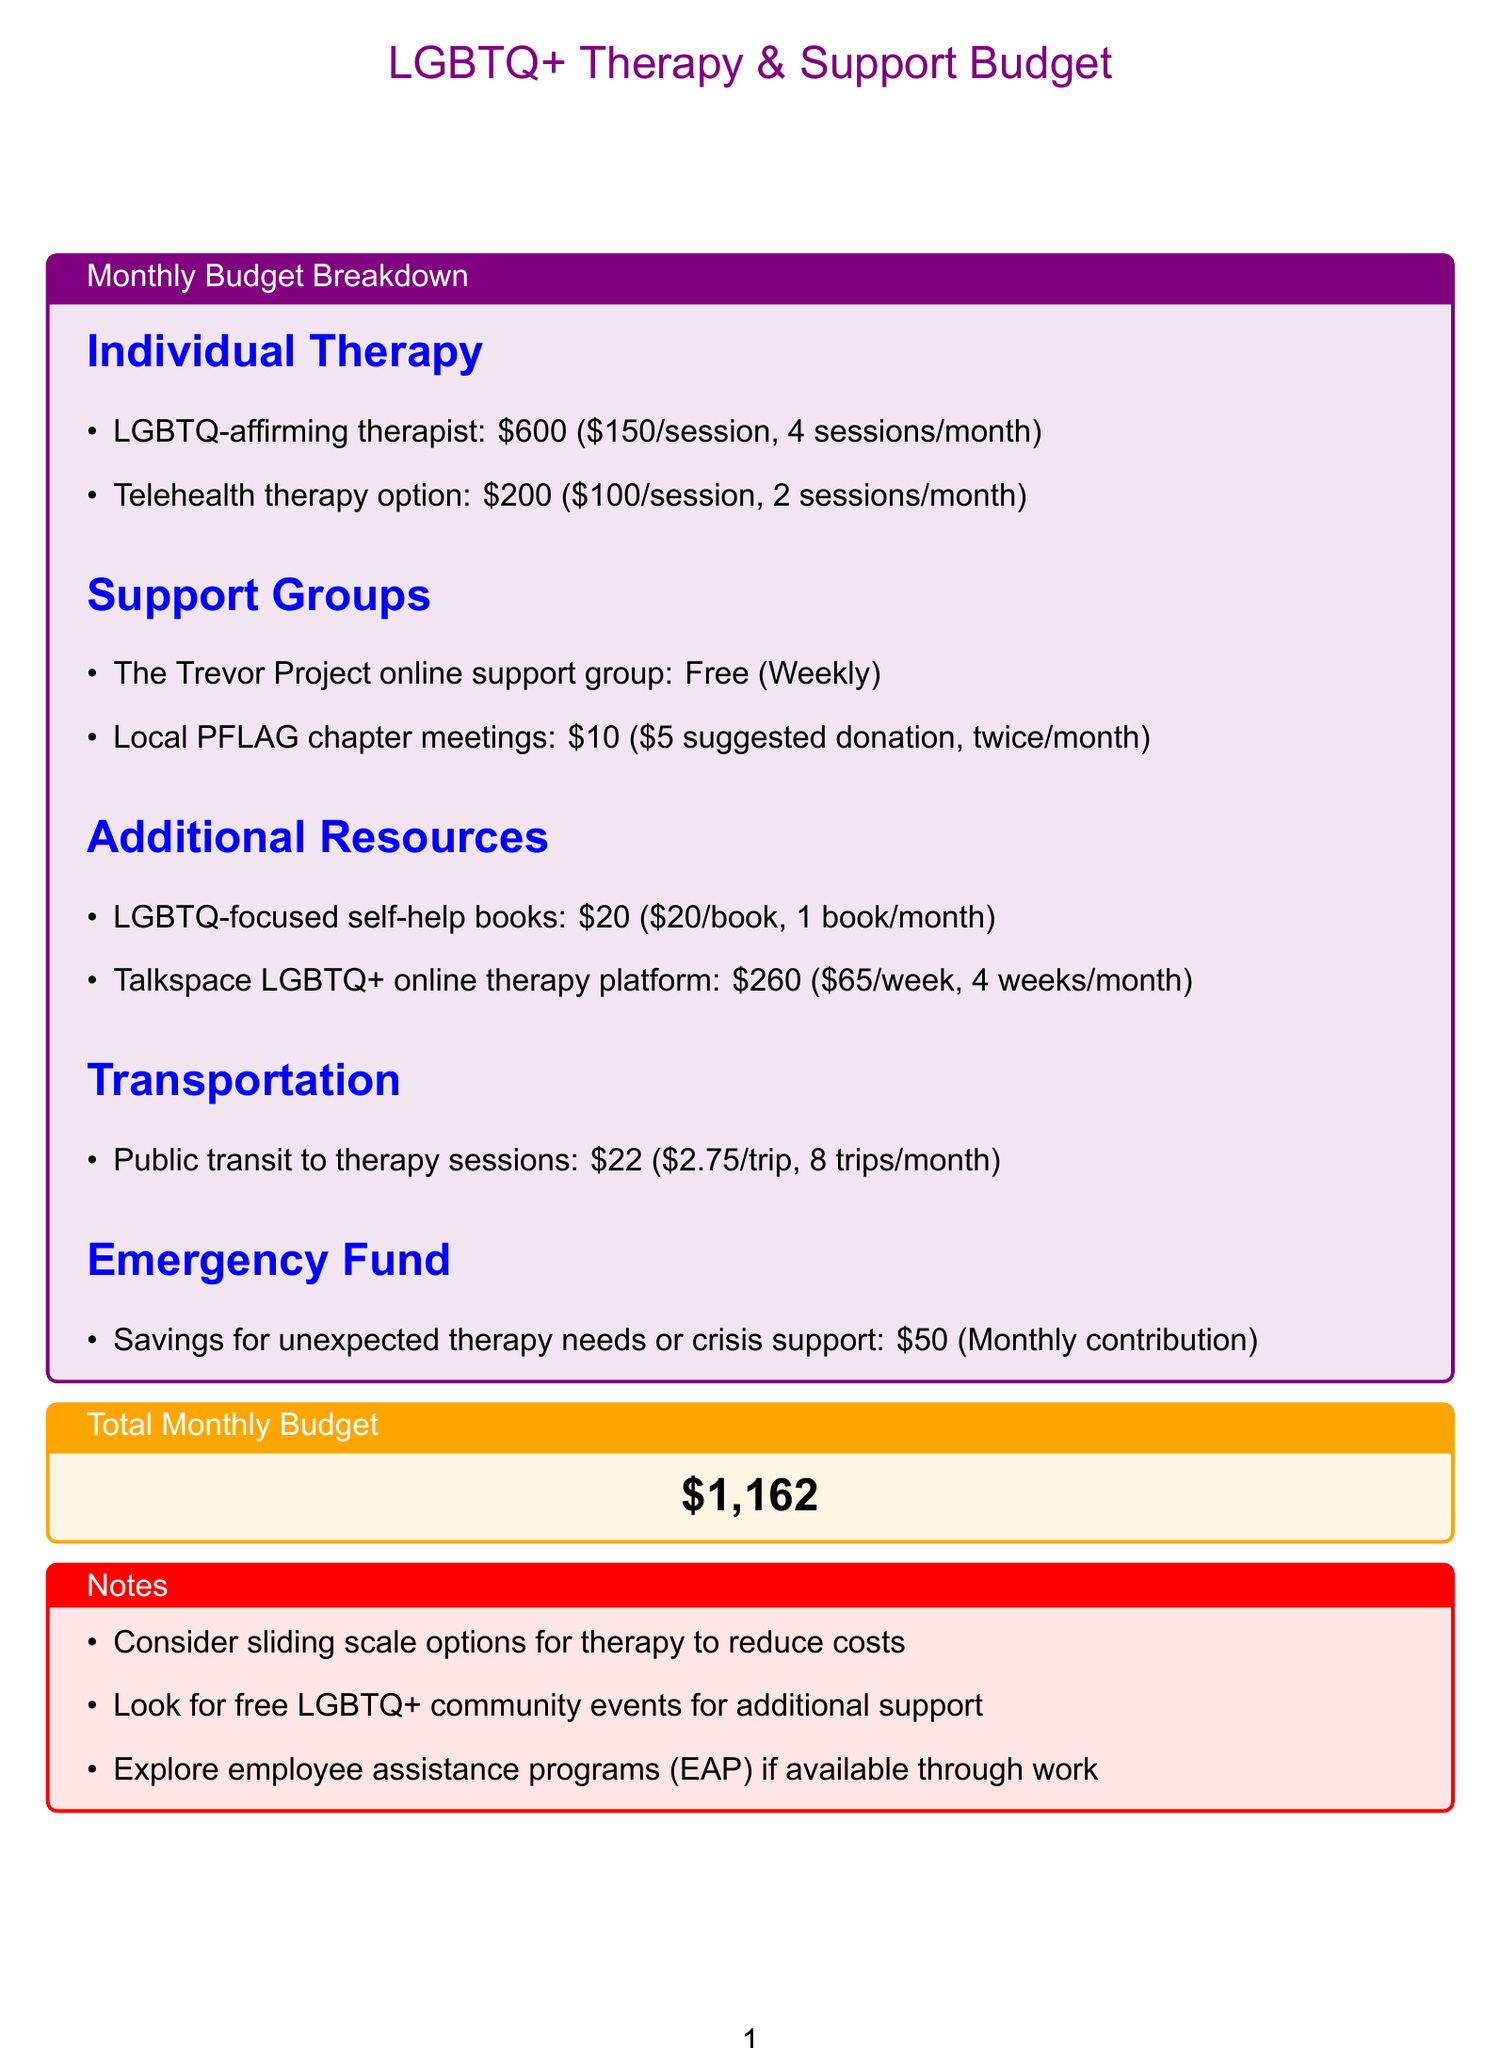What is the cost per session for the LGBTQ-affirming therapist? The document states that the LGBTQ-affirming therapist charges $150 per session.
Answer: $150 How many sessions per month are included for telehealth therapy? The telehealth therapy option includes 2 sessions per month.
Answer: 2 sessions What is the total budget for the month? The total monthly budget shown in the document is $1,162.
Answer: $1,162 How much is the suggested donation for local PFLAG chapter meetings? The suggested donation for local PFLAG chapter meetings is $5.
Answer: $5 What type of therapy does Talkspace provide? Talkspace is an online therapy platform tailored for LGBTQ+.
Answer: online therapy What monthly contribution is allocated for the emergency fund? The document indicates a monthly contribution of $50 for the emergency fund.
Answer: $50 How often does the Trevor Project online support group meet? The Trevor Project online support group meets weekly.
Answer: Weekly What is the total cost for the transportation to therapy sessions? The total cost for public transit to therapy sessions is $22.
Answer: $22 